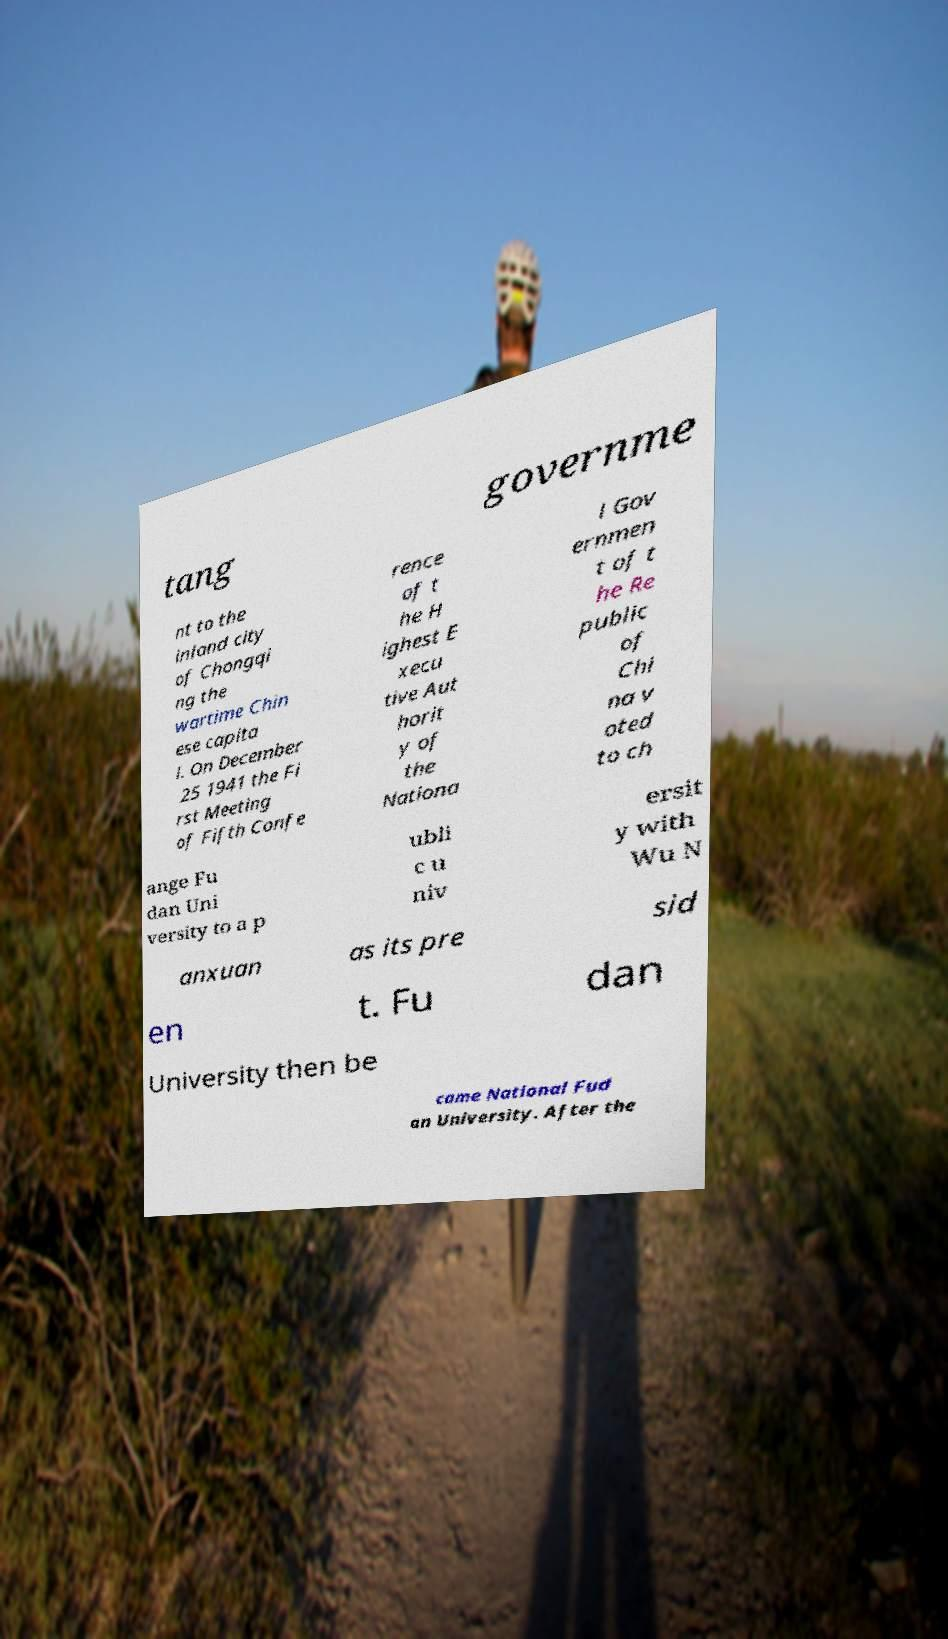I need the written content from this picture converted into text. Can you do that? tang governme nt to the inland city of Chongqi ng the wartime Chin ese capita l. On December 25 1941 the Fi rst Meeting of Fifth Confe rence of t he H ighest E xecu tive Aut horit y of the Nationa l Gov ernmen t of t he Re public of Chi na v oted to ch ange Fu dan Uni versity to a p ubli c u niv ersit y with Wu N anxuan as its pre sid en t. Fu dan University then be came National Fud an University. After the 